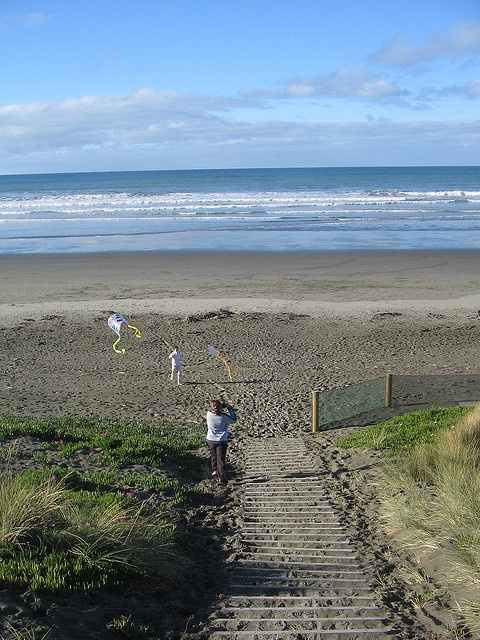Describe the objects in this image and their specific colors. I can see people in lightblue, black, gray, lightgray, and darkgray tones, kite in lightblue, lightgray, gray, khaki, and darkgray tones, people in lightblue, gray, white, and darkgray tones, and kite in lightblue, darkgray, tan, brown, and gray tones in this image. 